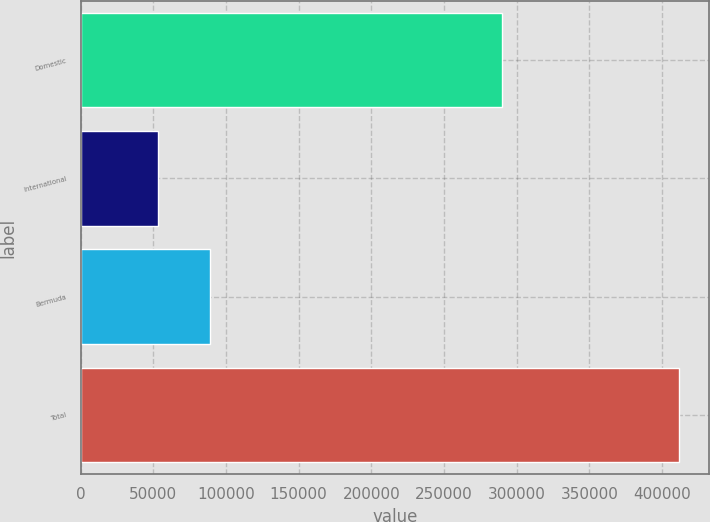Convert chart to OTSL. <chart><loc_0><loc_0><loc_500><loc_500><bar_chart><fcel>Domestic<fcel>International<fcel>Bermuda<fcel>Total<nl><fcel>289636<fcel>53186<fcel>89026.1<fcel>411587<nl></chart> 